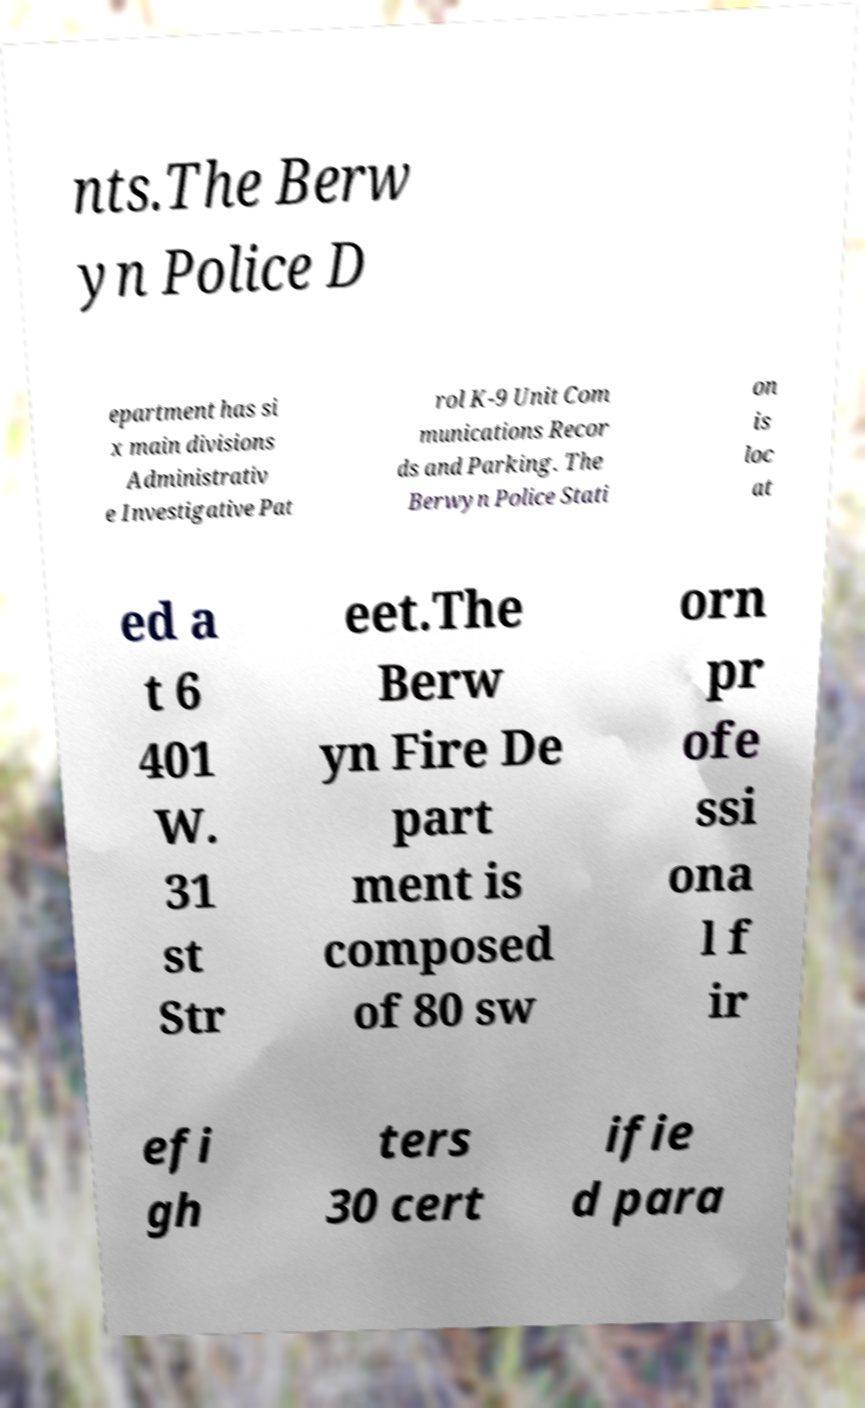Please read and relay the text visible in this image. What does it say? nts.The Berw yn Police D epartment has si x main divisions Administrativ e Investigative Pat rol K-9 Unit Com munications Recor ds and Parking. The Berwyn Police Stati on is loc at ed a t 6 401 W. 31 st Str eet.The Berw yn Fire De part ment is composed of 80 sw orn pr ofe ssi ona l f ir efi gh ters 30 cert ifie d para 